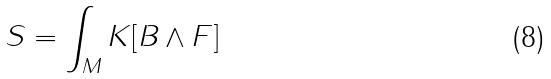Convert formula to latex. <formula><loc_0><loc_0><loc_500><loc_500>S = \int _ { M } K [ B \wedge F ]</formula> 